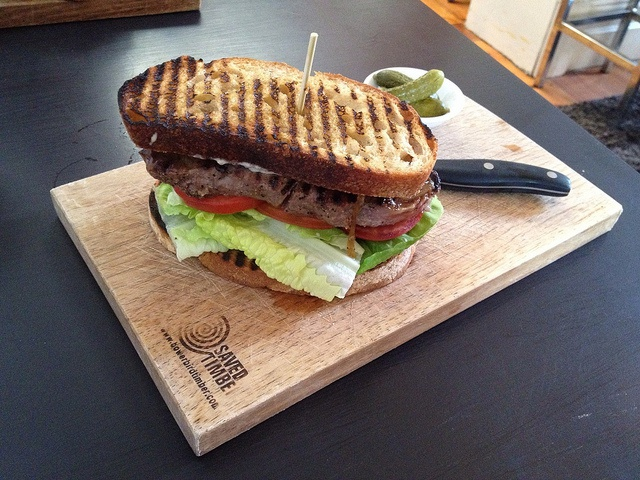Describe the objects in this image and their specific colors. I can see dining table in black, gray, and ivory tones, sandwich in gray, maroon, black, and tan tones, chair in gray, darkgray, and tan tones, knife in gray, black, and darkblue tones, and bowl in gray, white, darkgray, and beige tones in this image. 